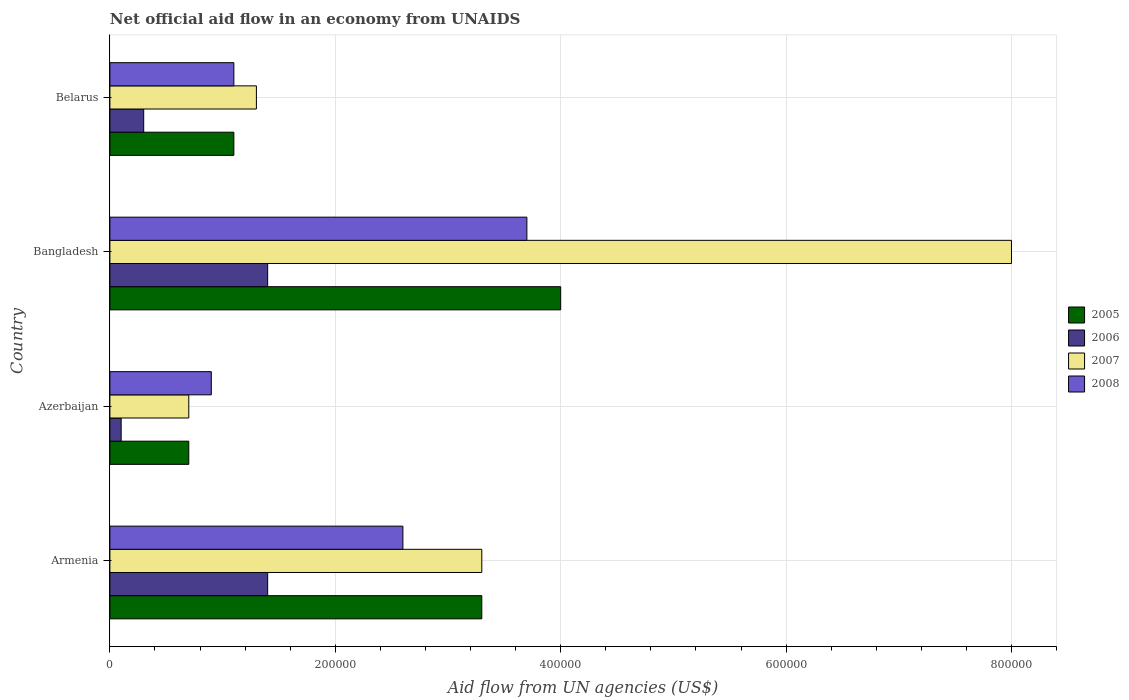Are the number of bars per tick equal to the number of legend labels?
Offer a terse response. Yes. What is the label of the 2nd group of bars from the top?
Keep it short and to the point. Bangladesh. In how many cases, is the number of bars for a given country not equal to the number of legend labels?
Offer a terse response. 0. In which country was the net official aid flow in 2006 minimum?
Make the answer very short. Azerbaijan. What is the difference between the net official aid flow in 2005 in Belarus and the net official aid flow in 2007 in Armenia?
Your answer should be compact. -2.20e+05. What is the average net official aid flow in 2008 per country?
Offer a very short reply. 2.08e+05. In how many countries, is the net official aid flow in 2005 greater than 40000 US$?
Keep it short and to the point. 4. What is the ratio of the net official aid flow in 2006 in Bangladesh to that in Belarus?
Make the answer very short. 4.67. What is the difference between the highest and the lowest net official aid flow in 2008?
Provide a succinct answer. 2.80e+05. Is it the case that in every country, the sum of the net official aid flow in 2006 and net official aid flow in 2007 is greater than the sum of net official aid flow in 2008 and net official aid flow in 2005?
Ensure brevity in your answer.  No. Is it the case that in every country, the sum of the net official aid flow in 2006 and net official aid flow in 2005 is greater than the net official aid flow in 2008?
Your response must be concise. No. How many countries are there in the graph?
Give a very brief answer. 4. Are the values on the major ticks of X-axis written in scientific E-notation?
Provide a succinct answer. No. Where does the legend appear in the graph?
Keep it short and to the point. Center right. How many legend labels are there?
Make the answer very short. 4. How are the legend labels stacked?
Your answer should be compact. Vertical. What is the title of the graph?
Provide a succinct answer. Net official aid flow in an economy from UNAIDS. Does "1972" appear as one of the legend labels in the graph?
Offer a terse response. No. What is the label or title of the X-axis?
Offer a very short reply. Aid flow from UN agencies (US$). What is the Aid flow from UN agencies (US$) of 2005 in Armenia?
Your answer should be compact. 3.30e+05. What is the Aid flow from UN agencies (US$) of 2006 in Armenia?
Keep it short and to the point. 1.40e+05. What is the Aid flow from UN agencies (US$) of 2008 in Armenia?
Keep it short and to the point. 2.60e+05. What is the Aid flow from UN agencies (US$) in 2005 in Azerbaijan?
Your answer should be compact. 7.00e+04. What is the Aid flow from UN agencies (US$) of 2006 in Bangladesh?
Provide a succinct answer. 1.40e+05. What is the Aid flow from UN agencies (US$) in 2005 in Belarus?
Your response must be concise. 1.10e+05. What is the Aid flow from UN agencies (US$) of 2006 in Belarus?
Offer a terse response. 3.00e+04. What is the Aid flow from UN agencies (US$) in 2007 in Belarus?
Your response must be concise. 1.30e+05. What is the Aid flow from UN agencies (US$) in 2008 in Belarus?
Offer a very short reply. 1.10e+05. Across all countries, what is the maximum Aid flow from UN agencies (US$) of 2006?
Your response must be concise. 1.40e+05. Across all countries, what is the maximum Aid flow from UN agencies (US$) of 2007?
Ensure brevity in your answer.  8.00e+05. Across all countries, what is the minimum Aid flow from UN agencies (US$) in 2007?
Your answer should be compact. 7.00e+04. What is the total Aid flow from UN agencies (US$) of 2005 in the graph?
Your answer should be compact. 9.10e+05. What is the total Aid flow from UN agencies (US$) of 2006 in the graph?
Your response must be concise. 3.20e+05. What is the total Aid flow from UN agencies (US$) of 2007 in the graph?
Provide a succinct answer. 1.33e+06. What is the total Aid flow from UN agencies (US$) in 2008 in the graph?
Make the answer very short. 8.30e+05. What is the difference between the Aid flow from UN agencies (US$) in 2005 in Armenia and that in Azerbaijan?
Keep it short and to the point. 2.60e+05. What is the difference between the Aid flow from UN agencies (US$) of 2007 in Armenia and that in Azerbaijan?
Offer a terse response. 2.60e+05. What is the difference between the Aid flow from UN agencies (US$) in 2005 in Armenia and that in Bangladesh?
Your answer should be very brief. -7.00e+04. What is the difference between the Aid flow from UN agencies (US$) of 2006 in Armenia and that in Bangladesh?
Offer a very short reply. 0. What is the difference between the Aid flow from UN agencies (US$) of 2007 in Armenia and that in Bangladesh?
Offer a terse response. -4.70e+05. What is the difference between the Aid flow from UN agencies (US$) in 2006 in Armenia and that in Belarus?
Your answer should be very brief. 1.10e+05. What is the difference between the Aid flow from UN agencies (US$) in 2007 in Armenia and that in Belarus?
Your response must be concise. 2.00e+05. What is the difference between the Aid flow from UN agencies (US$) of 2005 in Azerbaijan and that in Bangladesh?
Give a very brief answer. -3.30e+05. What is the difference between the Aid flow from UN agencies (US$) in 2006 in Azerbaijan and that in Bangladesh?
Provide a succinct answer. -1.30e+05. What is the difference between the Aid flow from UN agencies (US$) of 2007 in Azerbaijan and that in Bangladesh?
Keep it short and to the point. -7.30e+05. What is the difference between the Aid flow from UN agencies (US$) in 2008 in Azerbaijan and that in Bangladesh?
Your response must be concise. -2.80e+05. What is the difference between the Aid flow from UN agencies (US$) in 2005 in Bangladesh and that in Belarus?
Your response must be concise. 2.90e+05. What is the difference between the Aid flow from UN agencies (US$) of 2007 in Bangladesh and that in Belarus?
Your answer should be compact. 6.70e+05. What is the difference between the Aid flow from UN agencies (US$) in 2005 in Armenia and the Aid flow from UN agencies (US$) in 2006 in Azerbaijan?
Provide a succinct answer. 3.20e+05. What is the difference between the Aid flow from UN agencies (US$) of 2006 in Armenia and the Aid flow from UN agencies (US$) of 2008 in Azerbaijan?
Your answer should be compact. 5.00e+04. What is the difference between the Aid flow from UN agencies (US$) of 2005 in Armenia and the Aid flow from UN agencies (US$) of 2006 in Bangladesh?
Keep it short and to the point. 1.90e+05. What is the difference between the Aid flow from UN agencies (US$) of 2005 in Armenia and the Aid flow from UN agencies (US$) of 2007 in Bangladesh?
Your answer should be compact. -4.70e+05. What is the difference between the Aid flow from UN agencies (US$) in 2006 in Armenia and the Aid flow from UN agencies (US$) in 2007 in Bangladesh?
Your answer should be compact. -6.60e+05. What is the difference between the Aid flow from UN agencies (US$) of 2006 in Armenia and the Aid flow from UN agencies (US$) of 2008 in Bangladesh?
Provide a succinct answer. -2.30e+05. What is the difference between the Aid flow from UN agencies (US$) in 2007 in Armenia and the Aid flow from UN agencies (US$) in 2008 in Bangladesh?
Provide a succinct answer. -4.00e+04. What is the difference between the Aid flow from UN agencies (US$) in 2005 in Armenia and the Aid flow from UN agencies (US$) in 2007 in Belarus?
Ensure brevity in your answer.  2.00e+05. What is the difference between the Aid flow from UN agencies (US$) of 2005 in Azerbaijan and the Aid flow from UN agencies (US$) of 2006 in Bangladesh?
Your answer should be very brief. -7.00e+04. What is the difference between the Aid flow from UN agencies (US$) in 2005 in Azerbaijan and the Aid flow from UN agencies (US$) in 2007 in Bangladesh?
Offer a terse response. -7.30e+05. What is the difference between the Aid flow from UN agencies (US$) of 2005 in Azerbaijan and the Aid flow from UN agencies (US$) of 2008 in Bangladesh?
Make the answer very short. -3.00e+05. What is the difference between the Aid flow from UN agencies (US$) of 2006 in Azerbaijan and the Aid flow from UN agencies (US$) of 2007 in Bangladesh?
Ensure brevity in your answer.  -7.90e+05. What is the difference between the Aid flow from UN agencies (US$) of 2006 in Azerbaijan and the Aid flow from UN agencies (US$) of 2008 in Bangladesh?
Make the answer very short. -3.60e+05. What is the difference between the Aid flow from UN agencies (US$) in 2007 in Azerbaijan and the Aid flow from UN agencies (US$) in 2008 in Bangladesh?
Keep it short and to the point. -3.00e+05. What is the difference between the Aid flow from UN agencies (US$) in 2005 in Azerbaijan and the Aid flow from UN agencies (US$) in 2007 in Belarus?
Give a very brief answer. -6.00e+04. What is the difference between the Aid flow from UN agencies (US$) of 2006 in Azerbaijan and the Aid flow from UN agencies (US$) of 2007 in Belarus?
Offer a terse response. -1.20e+05. What is the difference between the Aid flow from UN agencies (US$) of 2007 in Azerbaijan and the Aid flow from UN agencies (US$) of 2008 in Belarus?
Offer a terse response. -4.00e+04. What is the difference between the Aid flow from UN agencies (US$) of 2006 in Bangladesh and the Aid flow from UN agencies (US$) of 2008 in Belarus?
Give a very brief answer. 3.00e+04. What is the difference between the Aid flow from UN agencies (US$) of 2007 in Bangladesh and the Aid flow from UN agencies (US$) of 2008 in Belarus?
Provide a succinct answer. 6.90e+05. What is the average Aid flow from UN agencies (US$) in 2005 per country?
Provide a succinct answer. 2.28e+05. What is the average Aid flow from UN agencies (US$) of 2007 per country?
Provide a short and direct response. 3.32e+05. What is the average Aid flow from UN agencies (US$) of 2008 per country?
Provide a short and direct response. 2.08e+05. What is the difference between the Aid flow from UN agencies (US$) of 2005 and Aid flow from UN agencies (US$) of 2006 in Armenia?
Your response must be concise. 1.90e+05. What is the difference between the Aid flow from UN agencies (US$) of 2005 and Aid flow from UN agencies (US$) of 2006 in Azerbaijan?
Offer a terse response. 6.00e+04. What is the difference between the Aid flow from UN agencies (US$) in 2005 and Aid flow from UN agencies (US$) in 2007 in Azerbaijan?
Make the answer very short. 0. What is the difference between the Aid flow from UN agencies (US$) of 2006 and Aid flow from UN agencies (US$) of 2008 in Azerbaijan?
Provide a short and direct response. -8.00e+04. What is the difference between the Aid flow from UN agencies (US$) in 2007 and Aid flow from UN agencies (US$) in 2008 in Azerbaijan?
Give a very brief answer. -2.00e+04. What is the difference between the Aid flow from UN agencies (US$) in 2005 and Aid flow from UN agencies (US$) in 2006 in Bangladesh?
Offer a terse response. 2.60e+05. What is the difference between the Aid flow from UN agencies (US$) in 2005 and Aid flow from UN agencies (US$) in 2007 in Bangladesh?
Make the answer very short. -4.00e+05. What is the difference between the Aid flow from UN agencies (US$) of 2006 and Aid flow from UN agencies (US$) of 2007 in Bangladesh?
Your answer should be very brief. -6.60e+05. What is the difference between the Aid flow from UN agencies (US$) in 2006 and Aid flow from UN agencies (US$) in 2008 in Bangladesh?
Ensure brevity in your answer.  -2.30e+05. What is the difference between the Aid flow from UN agencies (US$) of 2007 and Aid flow from UN agencies (US$) of 2008 in Bangladesh?
Offer a very short reply. 4.30e+05. What is the difference between the Aid flow from UN agencies (US$) in 2005 and Aid flow from UN agencies (US$) in 2007 in Belarus?
Give a very brief answer. -2.00e+04. What is the difference between the Aid flow from UN agencies (US$) of 2006 and Aid flow from UN agencies (US$) of 2008 in Belarus?
Offer a very short reply. -8.00e+04. What is the difference between the Aid flow from UN agencies (US$) in 2007 and Aid flow from UN agencies (US$) in 2008 in Belarus?
Offer a terse response. 2.00e+04. What is the ratio of the Aid flow from UN agencies (US$) of 2005 in Armenia to that in Azerbaijan?
Offer a terse response. 4.71. What is the ratio of the Aid flow from UN agencies (US$) in 2007 in Armenia to that in Azerbaijan?
Give a very brief answer. 4.71. What is the ratio of the Aid flow from UN agencies (US$) in 2008 in Armenia to that in Azerbaijan?
Your answer should be compact. 2.89. What is the ratio of the Aid flow from UN agencies (US$) in 2005 in Armenia to that in Bangladesh?
Ensure brevity in your answer.  0.82. What is the ratio of the Aid flow from UN agencies (US$) in 2007 in Armenia to that in Bangladesh?
Keep it short and to the point. 0.41. What is the ratio of the Aid flow from UN agencies (US$) of 2008 in Armenia to that in Bangladesh?
Offer a terse response. 0.7. What is the ratio of the Aid flow from UN agencies (US$) of 2005 in Armenia to that in Belarus?
Your response must be concise. 3. What is the ratio of the Aid flow from UN agencies (US$) in 2006 in Armenia to that in Belarus?
Your response must be concise. 4.67. What is the ratio of the Aid flow from UN agencies (US$) of 2007 in Armenia to that in Belarus?
Offer a very short reply. 2.54. What is the ratio of the Aid flow from UN agencies (US$) in 2008 in Armenia to that in Belarus?
Offer a terse response. 2.36. What is the ratio of the Aid flow from UN agencies (US$) in 2005 in Azerbaijan to that in Bangladesh?
Your answer should be very brief. 0.17. What is the ratio of the Aid flow from UN agencies (US$) in 2006 in Azerbaijan to that in Bangladesh?
Keep it short and to the point. 0.07. What is the ratio of the Aid flow from UN agencies (US$) in 2007 in Azerbaijan to that in Bangladesh?
Make the answer very short. 0.09. What is the ratio of the Aid flow from UN agencies (US$) of 2008 in Azerbaijan to that in Bangladesh?
Provide a short and direct response. 0.24. What is the ratio of the Aid flow from UN agencies (US$) of 2005 in Azerbaijan to that in Belarus?
Make the answer very short. 0.64. What is the ratio of the Aid flow from UN agencies (US$) in 2006 in Azerbaijan to that in Belarus?
Offer a terse response. 0.33. What is the ratio of the Aid flow from UN agencies (US$) in 2007 in Azerbaijan to that in Belarus?
Provide a short and direct response. 0.54. What is the ratio of the Aid flow from UN agencies (US$) of 2008 in Azerbaijan to that in Belarus?
Ensure brevity in your answer.  0.82. What is the ratio of the Aid flow from UN agencies (US$) in 2005 in Bangladesh to that in Belarus?
Provide a short and direct response. 3.64. What is the ratio of the Aid flow from UN agencies (US$) of 2006 in Bangladesh to that in Belarus?
Provide a succinct answer. 4.67. What is the ratio of the Aid flow from UN agencies (US$) of 2007 in Bangladesh to that in Belarus?
Your answer should be very brief. 6.15. What is the ratio of the Aid flow from UN agencies (US$) in 2008 in Bangladesh to that in Belarus?
Make the answer very short. 3.36. What is the difference between the highest and the second highest Aid flow from UN agencies (US$) in 2007?
Your answer should be compact. 4.70e+05. What is the difference between the highest and the lowest Aid flow from UN agencies (US$) of 2005?
Give a very brief answer. 3.30e+05. What is the difference between the highest and the lowest Aid flow from UN agencies (US$) of 2006?
Provide a short and direct response. 1.30e+05. What is the difference between the highest and the lowest Aid flow from UN agencies (US$) in 2007?
Keep it short and to the point. 7.30e+05. 